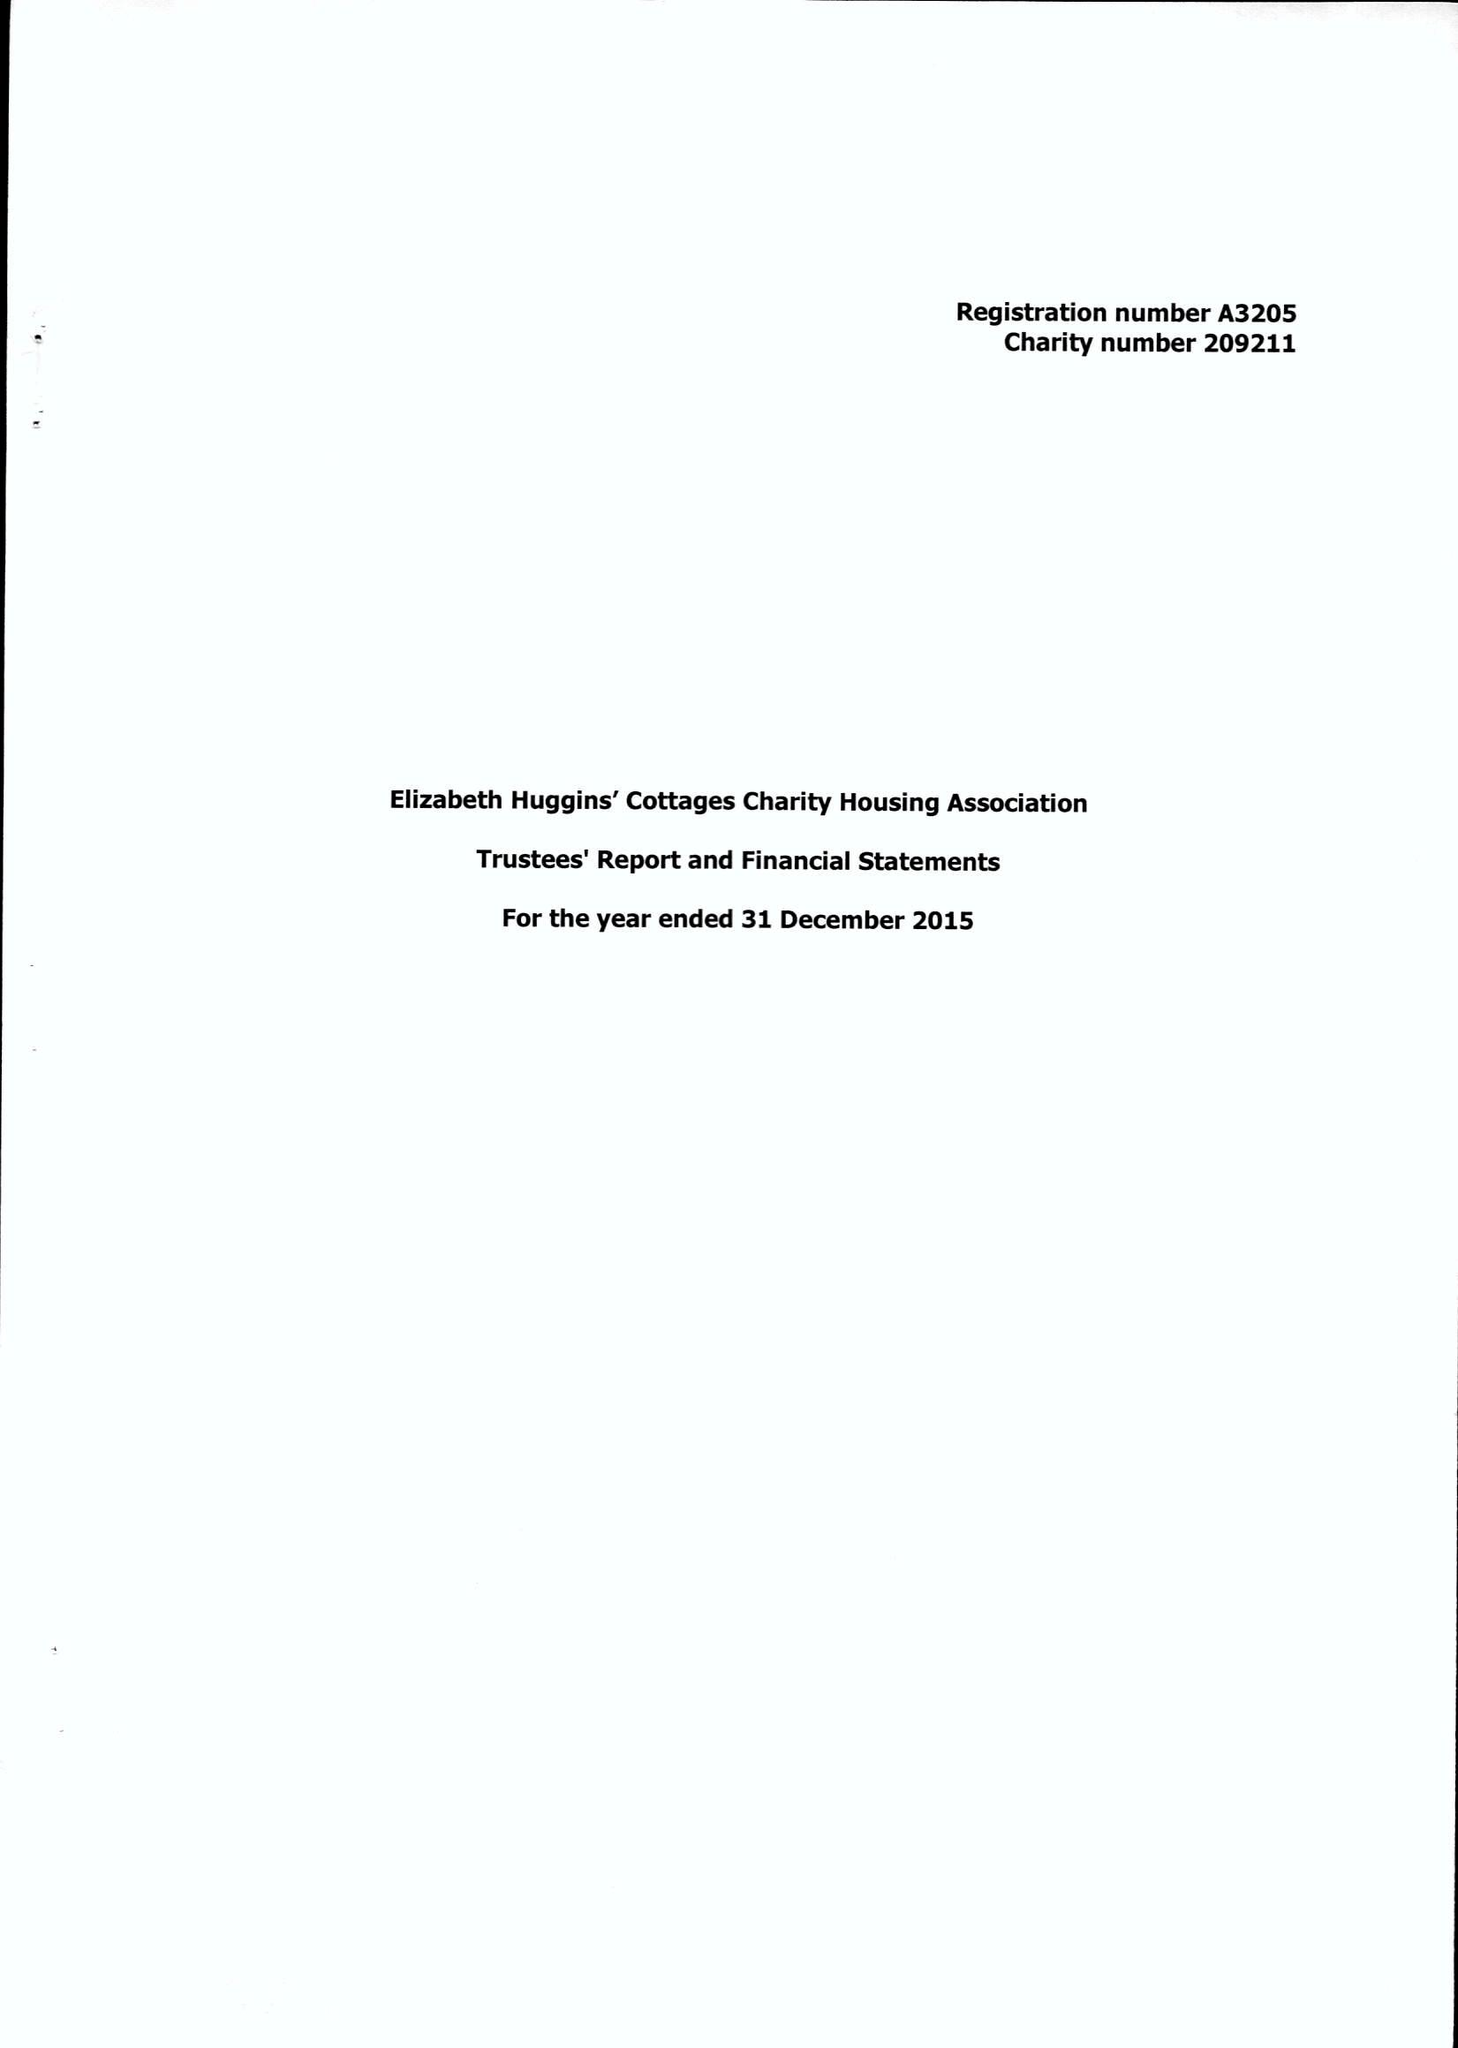What is the value for the address__postcode?
Answer the question using a single word or phrase. DA11 9JQ 